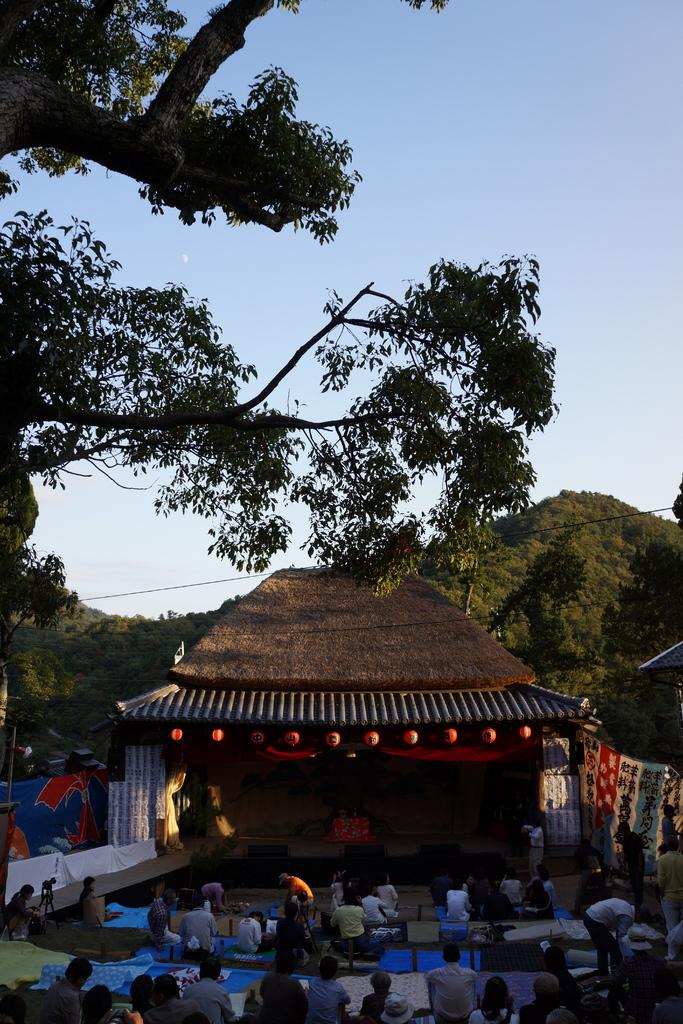What is the main structure in the image? There is a stage in the image. What is located in front of the stage? There is a hut in front of the stage. What are the people in the image doing? There are people sitting on mats in the image. What type of natural element can be seen in the image? There is a tree in the image. What is visible in the background of the image? There is a mountain visible behind the stage. How many pizzas are being served on the stage in the image? There are no pizzas present in the image. What is the cause of death for the person sitting on the mat in the image? There is no indication of death or any deceased person in the image. 